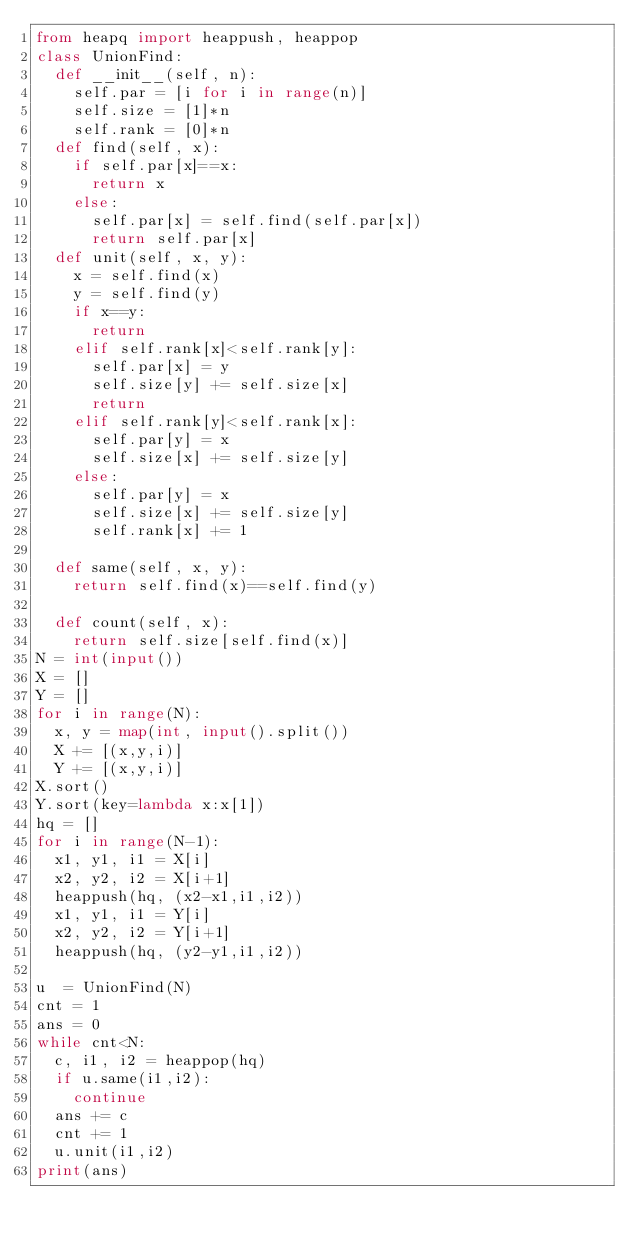Convert code to text. <code><loc_0><loc_0><loc_500><loc_500><_Python_>from heapq import heappush, heappop
class UnionFind:
  def __init__(self, n):
    self.par = [i for i in range(n)]
    self.size = [1]*n
    self.rank = [0]*n
  def find(self, x):
    if self.par[x]==x:
      return x
    else:
      self.par[x] = self.find(self.par[x])
      return self.par[x]
  def unit(self, x, y):
    x = self.find(x)
    y = self.find(y)
    if x==y:
      return
    elif self.rank[x]<self.rank[y]:
      self.par[x] = y
      self.size[y] += self.size[x]
      return
    elif self.rank[y]<self.rank[x]:
      self.par[y] = x
      self.size[x] += self.size[y]
    else:
      self.par[y] = x
      self.size[x] += self.size[y]
      self.rank[x] += 1
      
  def same(self, x, y):
    return self.find(x)==self.find(y)
  
  def count(self, x):
    return self.size[self.find(x)]
N = int(input())
X = []
Y = []
for i in range(N):
  x, y = map(int, input().split())
  X += [(x,y,i)]
  Y += [(x,y,i)]
X.sort()
Y.sort(key=lambda x:x[1])
hq = []
for i in range(N-1):
  x1, y1, i1 = X[i]
  x2, y2, i2 = X[i+1]
  heappush(hq, (x2-x1,i1,i2))
  x1, y1, i1 = Y[i]
  x2, y2, i2 = Y[i+1]
  heappush(hq, (y2-y1,i1,i2))

u  = UnionFind(N)
cnt = 1
ans = 0
while cnt<N:
  c, i1, i2 = heappop(hq)
  if u.same(i1,i2):
    continue
  ans += c
  cnt += 1
  u.unit(i1,i2)
print(ans)</code> 